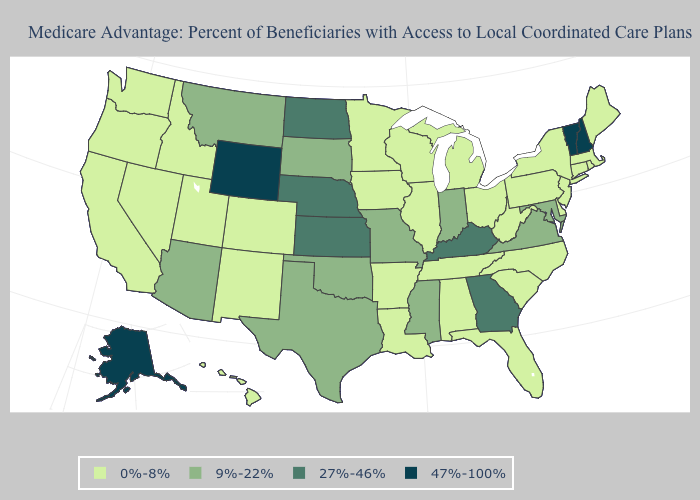What is the lowest value in the MidWest?
Be succinct. 0%-8%. Does West Virginia have the lowest value in the USA?
Give a very brief answer. Yes. Name the states that have a value in the range 0%-8%?
Give a very brief answer. Alabama, Arkansas, California, Colorado, Connecticut, Delaware, Florida, Hawaii, Iowa, Idaho, Illinois, Louisiana, Massachusetts, Maine, Michigan, Minnesota, North Carolina, New Jersey, New Mexico, Nevada, New York, Ohio, Oregon, Pennsylvania, Rhode Island, South Carolina, Tennessee, Utah, Washington, Wisconsin, West Virginia. Does Washington have the same value as Utah?
Write a very short answer. Yes. Does Missouri have the lowest value in the MidWest?
Be succinct. No. What is the lowest value in states that border Missouri?
Be succinct. 0%-8%. Does West Virginia have the highest value in the USA?
Short answer required. No. Which states have the highest value in the USA?
Be succinct. Alaska, New Hampshire, Vermont, Wyoming. Does the map have missing data?
Give a very brief answer. No. Which states have the highest value in the USA?
Quick response, please. Alaska, New Hampshire, Vermont, Wyoming. Is the legend a continuous bar?
Write a very short answer. No. Name the states that have a value in the range 9%-22%?
Give a very brief answer. Arizona, Indiana, Maryland, Missouri, Mississippi, Montana, Oklahoma, South Dakota, Texas, Virginia. Among the states that border Indiana , which have the lowest value?
Concise answer only. Illinois, Michigan, Ohio. How many symbols are there in the legend?
Answer briefly. 4. 